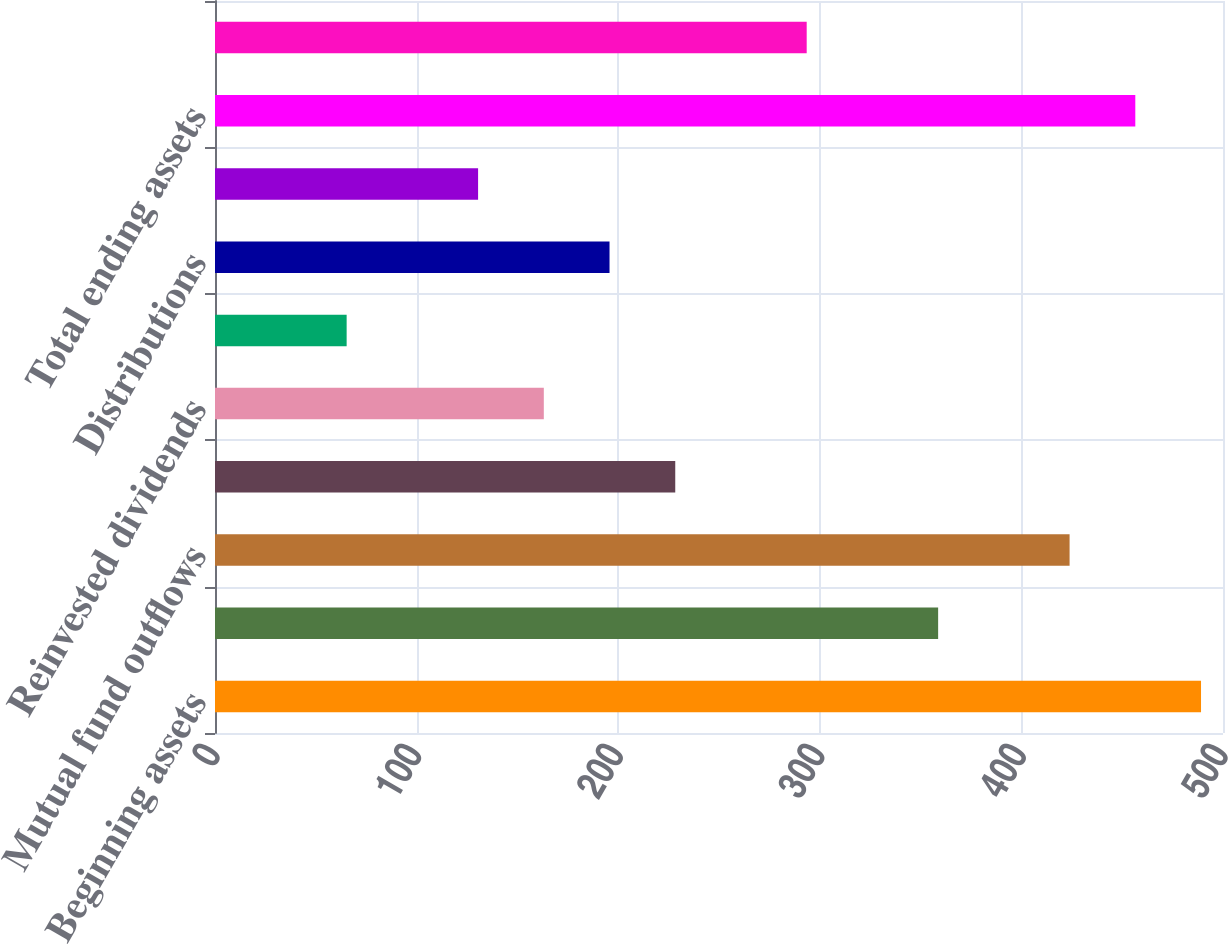Convert chart to OTSL. <chart><loc_0><loc_0><loc_500><loc_500><bar_chart><fcel>Beginning assets<fcel>Mutual fund inflows<fcel>Mutual fund outflows<fcel>Net new flows<fcel>Reinvested dividends<fcel>Net flows<fcel>Distributions<fcel>Market appreciation<fcel>Total ending assets<fcel>Inflows<nl><fcel>489.1<fcel>358.7<fcel>423.9<fcel>228.3<fcel>163.1<fcel>65.3<fcel>195.7<fcel>130.5<fcel>456.5<fcel>293.5<nl></chart> 